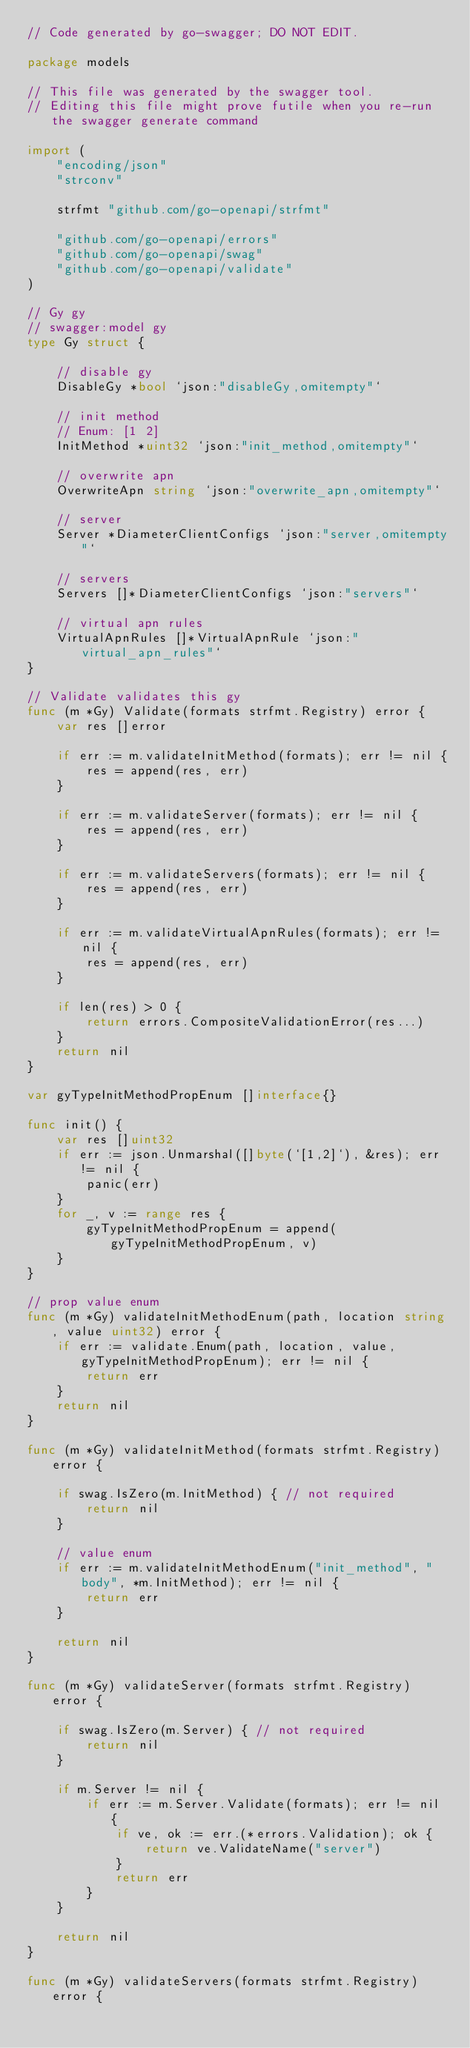<code> <loc_0><loc_0><loc_500><loc_500><_Go_>// Code generated by go-swagger; DO NOT EDIT.

package models

// This file was generated by the swagger tool.
// Editing this file might prove futile when you re-run the swagger generate command

import (
	"encoding/json"
	"strconv"

	strfmt "github.com/go-openapi/strfmt"

	"github.com/go-openapi/errors"
	"github.com/go-openapi/swag"
	"github.com/go-openapi/validate"
)

// Gy gy
// swagger:model gy
type Gy struct {

	// disable gy
	DisableGy *bool `json:"disableGy,omitempty"`

	// init method
	// Enum: [1 2]
	InitMethod *uint32 `json:"init_method,omitempty"`

	// overwrite apn
	OverwriteApn string `json:"overwrite_apn,omitempty"`

	// server
	Server *DiameterClientConfigs `json:"server,omitempty"`

	// servers
	Servers []*DiameterClientConfigs `json:"servers"`

	// virtual apn rules
	VirtualApnRules []*VirtualApnRule `json:"virtual_apn_rules"`
}

// Validate validates this gy
func (m *Gy) Validate(formats strfmt.Registry) error {
	var res []error

	if err := m.validateInitMethod(formats); err != nil {
		res = append(res, err)
	}

	if err := m.validateServer(formats); err != nil {
		res = append(res, err)
	}

	if err := m.validateServers(formats); err != nil {
		res = append(res, err)
	}

	if err := m.validateVirtualApnRules(formats); err != nil {
		res = append(res, err)
	}

	if len(res) > 0 {
		return errors.CompositeValidationError(res...)
	}
	return nil
}

var gyTypeInitMethodPropEnum []interface{}

func init() {
	var res []uint32
	if err := json.Unmarshal([]byte(`[1,2]`), &res); err != nil {
		panic(err)
	}
	for _, v := range res {
		gyTypeInitMethodPropEnum = append(gyTypeInitMethodPropEnum, v)
	}
}

// prop value enum
func (m *Gy) validateInitMethodEnum(path, location string, value uint32) error {
	if err := validate.Enum(path, location, value, gyTypeInitMethodPropEnum); err != nil {
		return err
	}
	return nil
}

func (m *Gy) validateInitMethod(formats strfmt.Registry) error {

	if swag.IsZero(m.InitMethod) { // not required
		return nil
	}

	// value enum
	if err := m.validateInitMethodEnum("init_method", "body", *m.InitMethod); err != nil {
		return err
	}

	return nil
}

func (m *Gy) validateServer(formats strfmt.Registry) error {

	if swag.IsZero(m.Server) { // not required
		return nil
	}

	if m.Server != nil {
		if err := m.Server.Validate(formats); err != nil {
			if ve, ok := err.(*errors.Validation); ok {
				return ve.ValidateName("server")
			}
			return err
		}
	}

	return nil
}

func (m *Gy) validateServers(formats strfmt.Registry) error {
</code> 